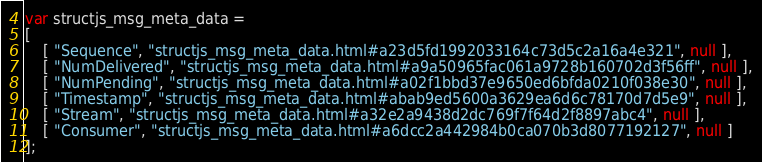Convert code to text. <code><loc_0><loc_0><loc_500><loc_500><_JavaScript_>var structjs_msg_meta_data =
[
    [ "Sequence", "structjs_msg_meta_data.html#a23d5fd1992033164c73d5c2a16a4e321", null ],
    [ "NumDelivered", "structjs_msg_meta_data.html#a9a50965fac061a9728b160702d3f56ff", null ],
    [ "NumPending", "structjs_msg_meta_data.html#a02f1bbd37e9650ed6bfda0210f038e30", null ],
    [ "Timestamp", "structjs_msg_meta_data.html#abab9ed5600a3629ea6d6c78170d7d5e9", null ],
    [ "Stream", "structjs_msg_meta_data.html#a32e2a9438d2dc769f7f64d2f8897abc4", null ],
    [ "Consumer", "structjs_msg_meta_data.html#a6dcc2a442984b0ca070b3d8077192127", null ]
];</code> 